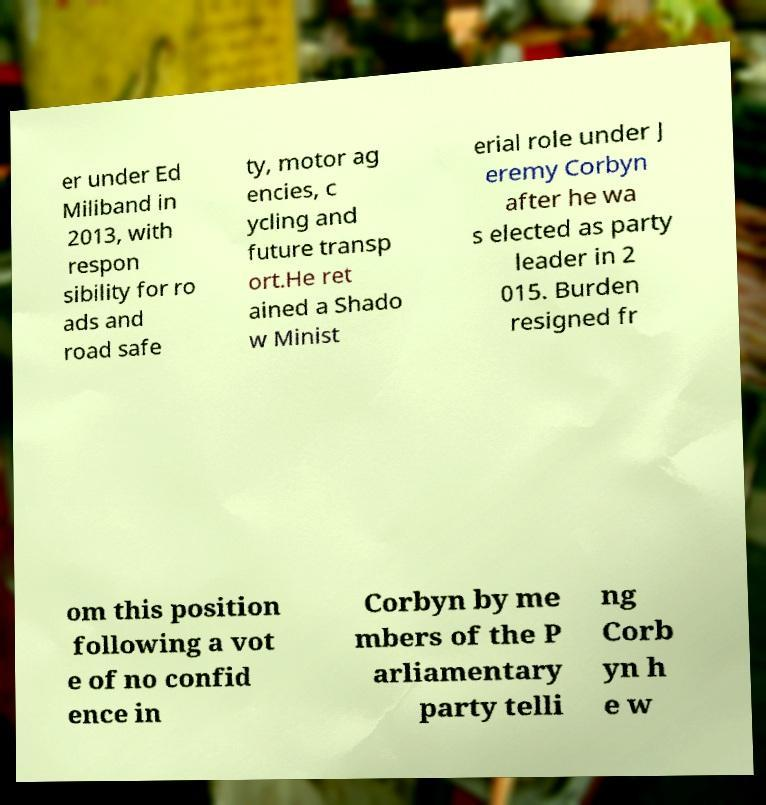Can you read and provide the text displayed in the image?This photo seems to have some interesting text. Can you extract and type it out for me? er under Ed Miliband in 2013, with respon sibility for ro ads and road safe ty, motor ag encies, c ycling and future transp ort.He ret ained a Shado w Minist erial role under J eremy Corbyn after he wa s elected as party leader in 2 015. Burden resigned fr om this position following a vot e of no confid ence in Corbyn by me mbers of the P arliamentary party telli ng Corb yn h e w 